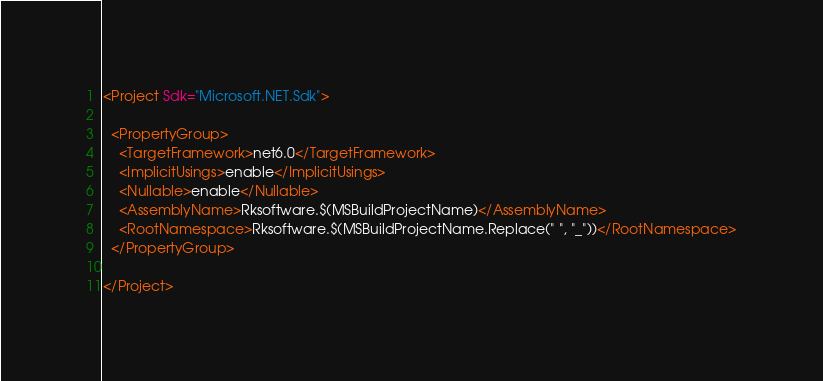<code> <loc_0><loc_0><loc_500><loc_500><_XML_><Project Sdk="Microsoft.NET.Sdk">

  <PropertyGroup>
    <TargetFramework>net6.0</TargetFramework>
    <ImplicitUsings>enable</ImplicitUsings>
    <Nullable>enable</Nullable>
    <AssemblyName>Rksoftware.$(MSBuildProjectName)</AssemblyName>
    <RootNamespace>Rksoftware.$(MSBuildProjectName.Replace(" ", "_"))</RootNamespace>
  </PropertyGroup>

</Project>
</code> 